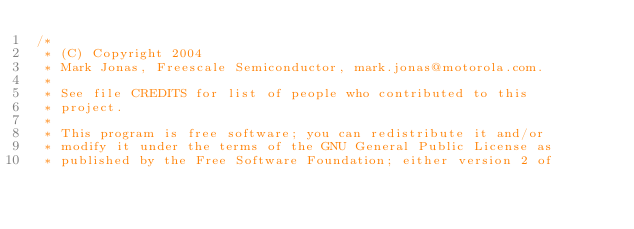<code> <loc_0><loc_0><loc_500><loc_500><_C_>/*
 * (C) Copyright 2004
 * Mark Jonas, Freescale Semiconductor, mark.jonas@motorola.com.
 *
 * See file CREDITS for list of people who contributed to this
 * project.
 *
 * This program is free software; you can redistribute it and/or
 * modify it under the terms of the GNU General Public License as
 * published by the Free Software Foundation; either version 2 of</code> 